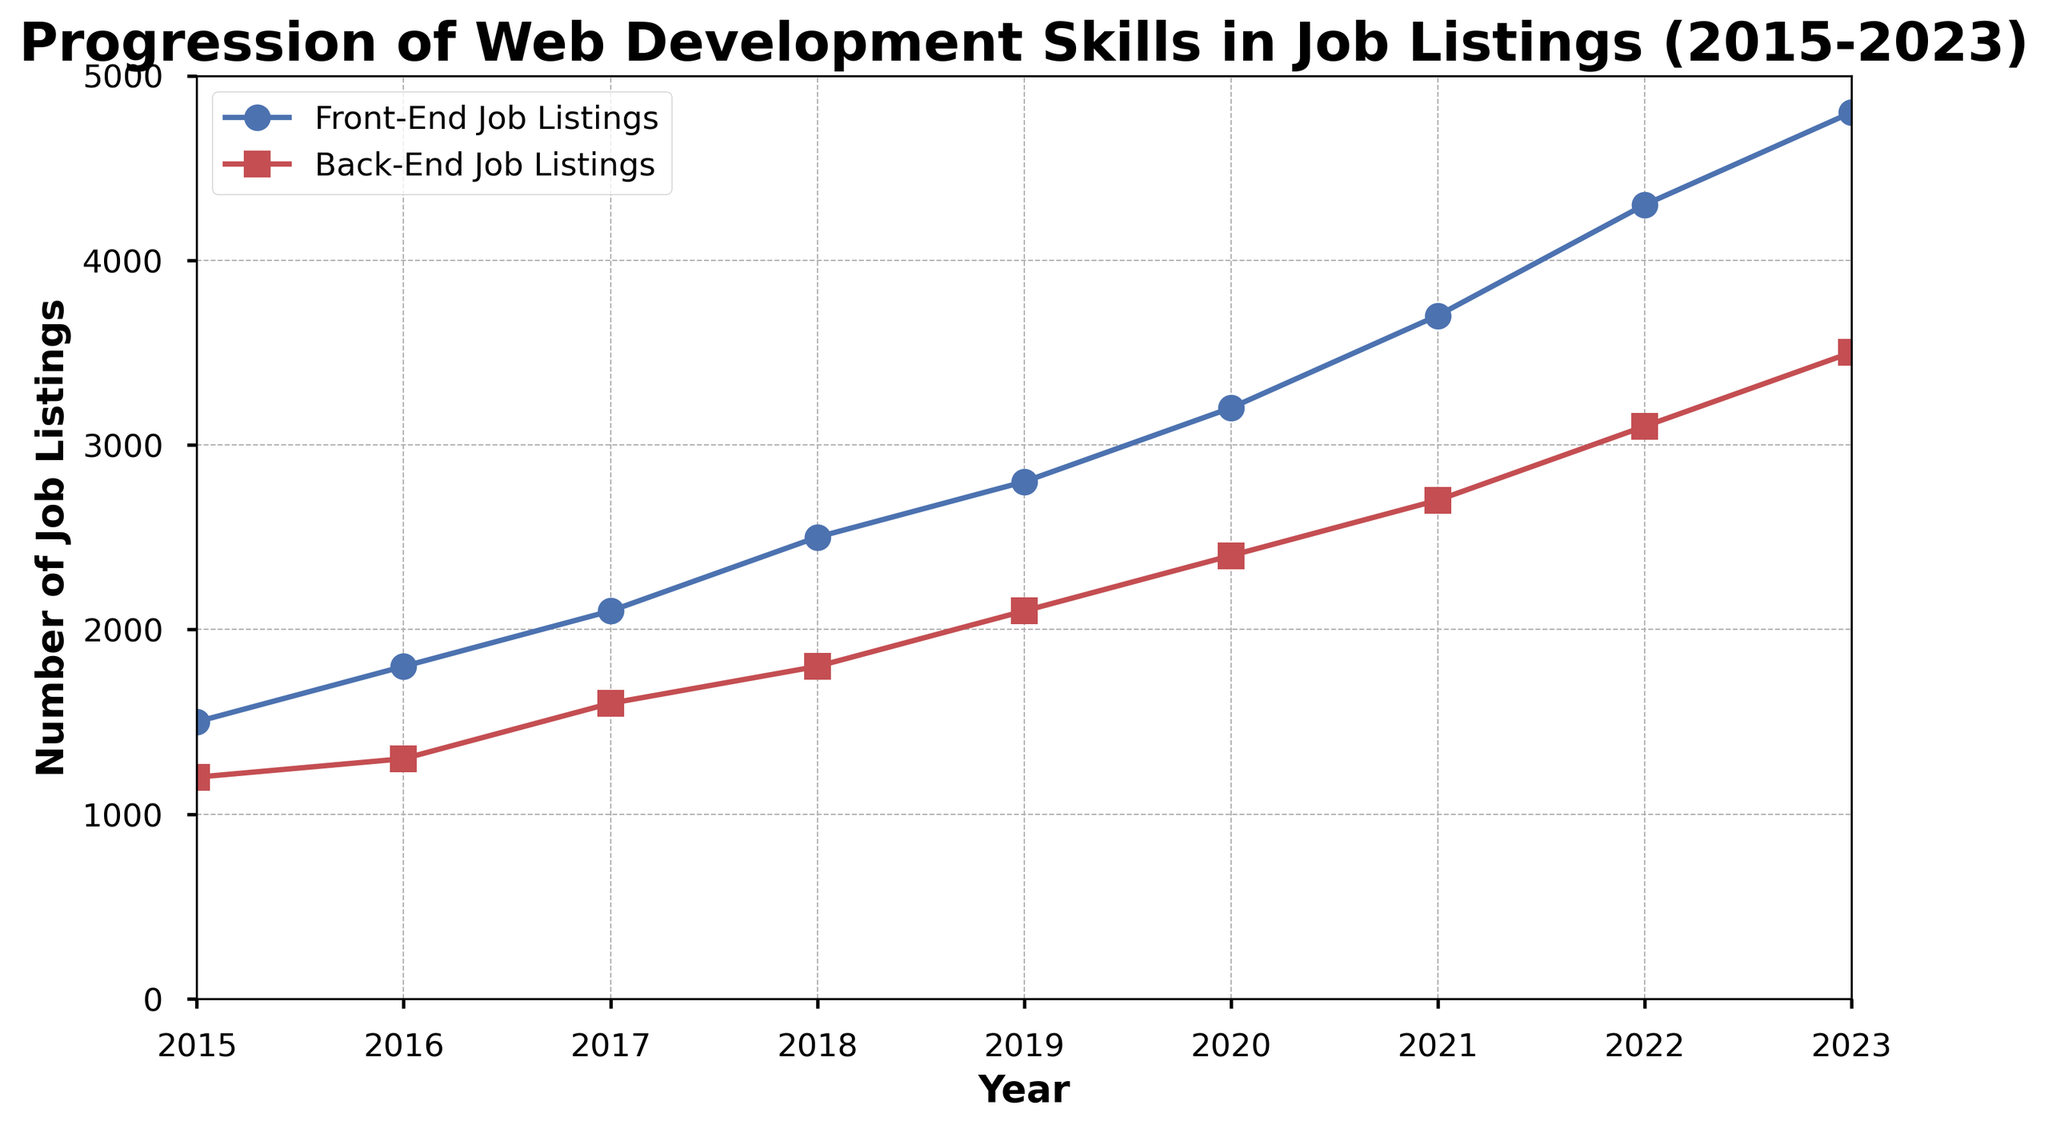How many more Front-End Job Listings were there in 2023 compared to 2015? To find how many more Front-End Job Listings were there in 2023 compared to 2015, subtract the number of Front-End Job Listings in 2015 from those in 2023. So, 4800 - 1500 = 3300
Answer: 3300 Which year saw the highest number of Back-End Job Listings? To determine which year had the highest number of Back-End Job Listings, look for the year with the highest data point for Back-End Job Listings. The highest value is 3500 in 2023
Answer: 2023 What is the average number of Front-End Job Listings from 2015 to 2023? To compute the average number of Front-End Job Listings, add up all the numbers for the years 2015 to 2023 and divide by the number of years. So, (1500 + 1800 + 2100 + 2500 + 2800 + 3200 + 3700 + 4300 + 4800) / 9 = 2978
Answer: 2978 By how much did the number of Back-End Job Listings increase from 2016 to 2020? Subtract the number of Back-End Job Listings in 2016 from the number in 2020. So, 2400 - 1300 = 1100
Answer: 1100 In what year did Front-End Job Listings first exceed 4000? Find the first year where the number of Front-End Job Listings is greater than 4000. This first occurs in 2022 with 4300 listings
Answer: 2022 What is the percentage increase in Back-End Job Listings from 2015 to 2023? Calculate the percentage increase by finding the difference between the values in 2023 and 2015, dividing by the 2015 value, and then multiplying by 100. So, ((3500 - 1200) / 1200) * 100 = 191.67%
Answer: 191.67% In which year was the difference between Front-End and Back-End Job Listings the smallest? To find the year with the smallest difference, subtract the number of Back-End Job Listings from Front-End Job Listings for each year and compare. The smallest difference is in 2015 (1500 - 1200 = 300)
Answer: 2015 Which category (Front-End or Back-End) had a greater rate of job listing increase between 2018 and 2023? Calculate the rate of increase for both categories. For Front-End, ((4800 - 2500) / 2500) * 100 = 92%. For Back-End, ((3500 - 1800) / 1800) * 100 = 94.44%. The Back-End category had a greater rate of increase.
Answer: Back-End How much was the average annual increase in Front-End Job Listings from 2015 to 2023? Subtract the number of Front-End Job Listings in 2015 from those in 2023, then divide by the number of years. So, (4800 - 1500) / (2023 - 2015) = 412.5
Answer: 412.5 Which year saw the highest increase in Back-End Job Listings compared to the previous year? Calculate the yearly increase by subtracting each preceding year's value from the current year's value and compare. 2021 had the highest increase: 2700 - 2400 = 300
Answer: 2021 